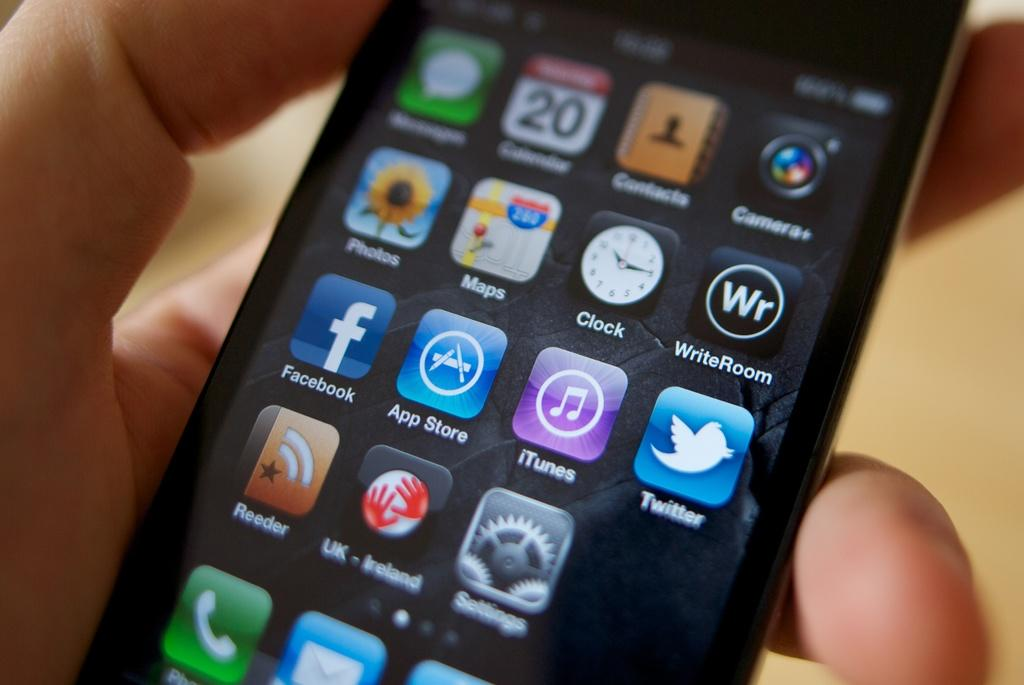<image>
Offer a succinct explanation of the picture presented. A person is holding a cell phone that shows that it is the 20th day of the month. 